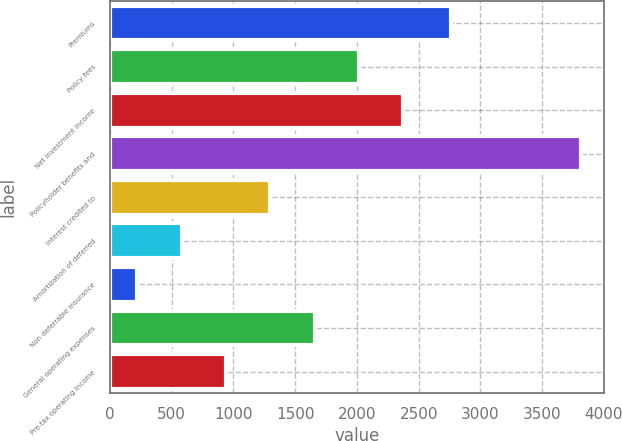Convert chart. <chart><loc_0><loc_0><loc_500><loc_500><bar_chart><fcel>Premiums<fcel>Policy fees<fcel>Net investment income<fcel>Policyholder benefits and<fcel>Interest credited to<fcel>Amortization of deferred<fcel>Non deferrable insurance<fcel>General operating expenses<fcel>Pre-tax operating income<nl><fcel>2759<fcel>2017<fcel>2376<fcel>3812<fcel>1299<fcel>581<fcel>222<fcel>1658<fcel>940<nl></chart> 